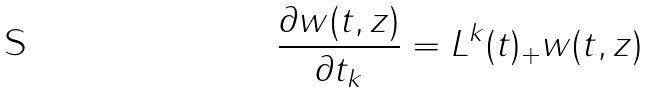Convert formula to latex. <formula><loc_0><loc_0><loc_500><loc_500>\frac { \partial { w ( t , z ) } } { \partial { t _ { k } } } = L ^ { k } ( t ) _ { + } w ( t , z )</formula> 